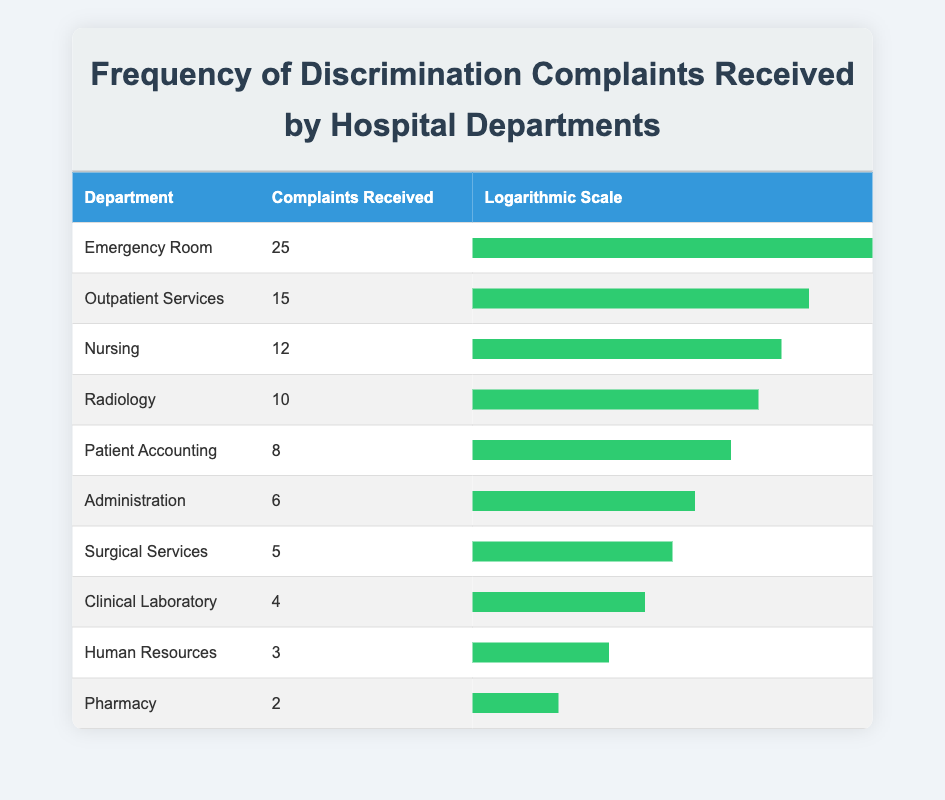What department received the highest number of discrimination complaints? The department with the highest number of complaints is listed in the table. The Emergency Room received 25 complaints, which is more than any other department.
Answer: Emergency Room How many complaints did the Nursing department receive? The table shows that the Nursing department received 12 complaints, which can be directly read from the complaints received column.
Answer: 12 What is the total number of discrimination complaints received across all departments? To find the total, sum the complaints from all departments: 25 + 15 + 12 + 10 + 8 + 6 + 5 + 4 + 3 + 2 = 90. Thus, the total number of complaints is 90.
Answer: 90 Is it true that the Pharmacy department received more than 3 complaints? The Pharmacy department is listed in the table with only 2 complaints received. Since 2 is less than 3, the statement is false.
Answer: No Which two departments received the fewest complaints combined? The departments with the fewest complaints are Human Resources and Pharmacy, with 3 and 2 complaints respectively. Adding these gives 3 + 2 = 5. Therefore, these two departments received the fewest complaints combined.
Answer: 5 What is the average number of discrimination complaints received by the departments? To calculate the average, sum all complaints (90) and divide by the number of departments (10): 90/10 = 9. Thus, the average number of complaints is 9.
Answer: 9 Which department's complaints are below the average number of complaints? The average number of complaints is 9. By checking each department's complaints, we find that Radiology (10), Patient Accounting (8), Administration (6), Surgical Services (5), Clinical Laboratory (4), Human Resources (3), and Pharmacy (2) all have complaints below the average.
Answer: Radiology, Patient Accounting, Administration, Surgical Services, Clinical Laboratory, Human Resources, Pharmacy How does the number of complaints in the Outpatient Services department compare to the Pharmacy department? Outpatient Services received 15 complaints, whereas the Pharmacy department received only 2 complaints. Therefore, Outpatient Services has significantly more complaints than Pharmacy.
Answer: Outpatient Services has more complaints than Pharmacy Which department has a logarithmic scale that represents approximately 55% of the maximum? Looking at the logarithmic scale provided in the table, Surgical Services has a bar width representing approximately 55%, indicating that it aligns with the given range.
Answer: Surgical Services 